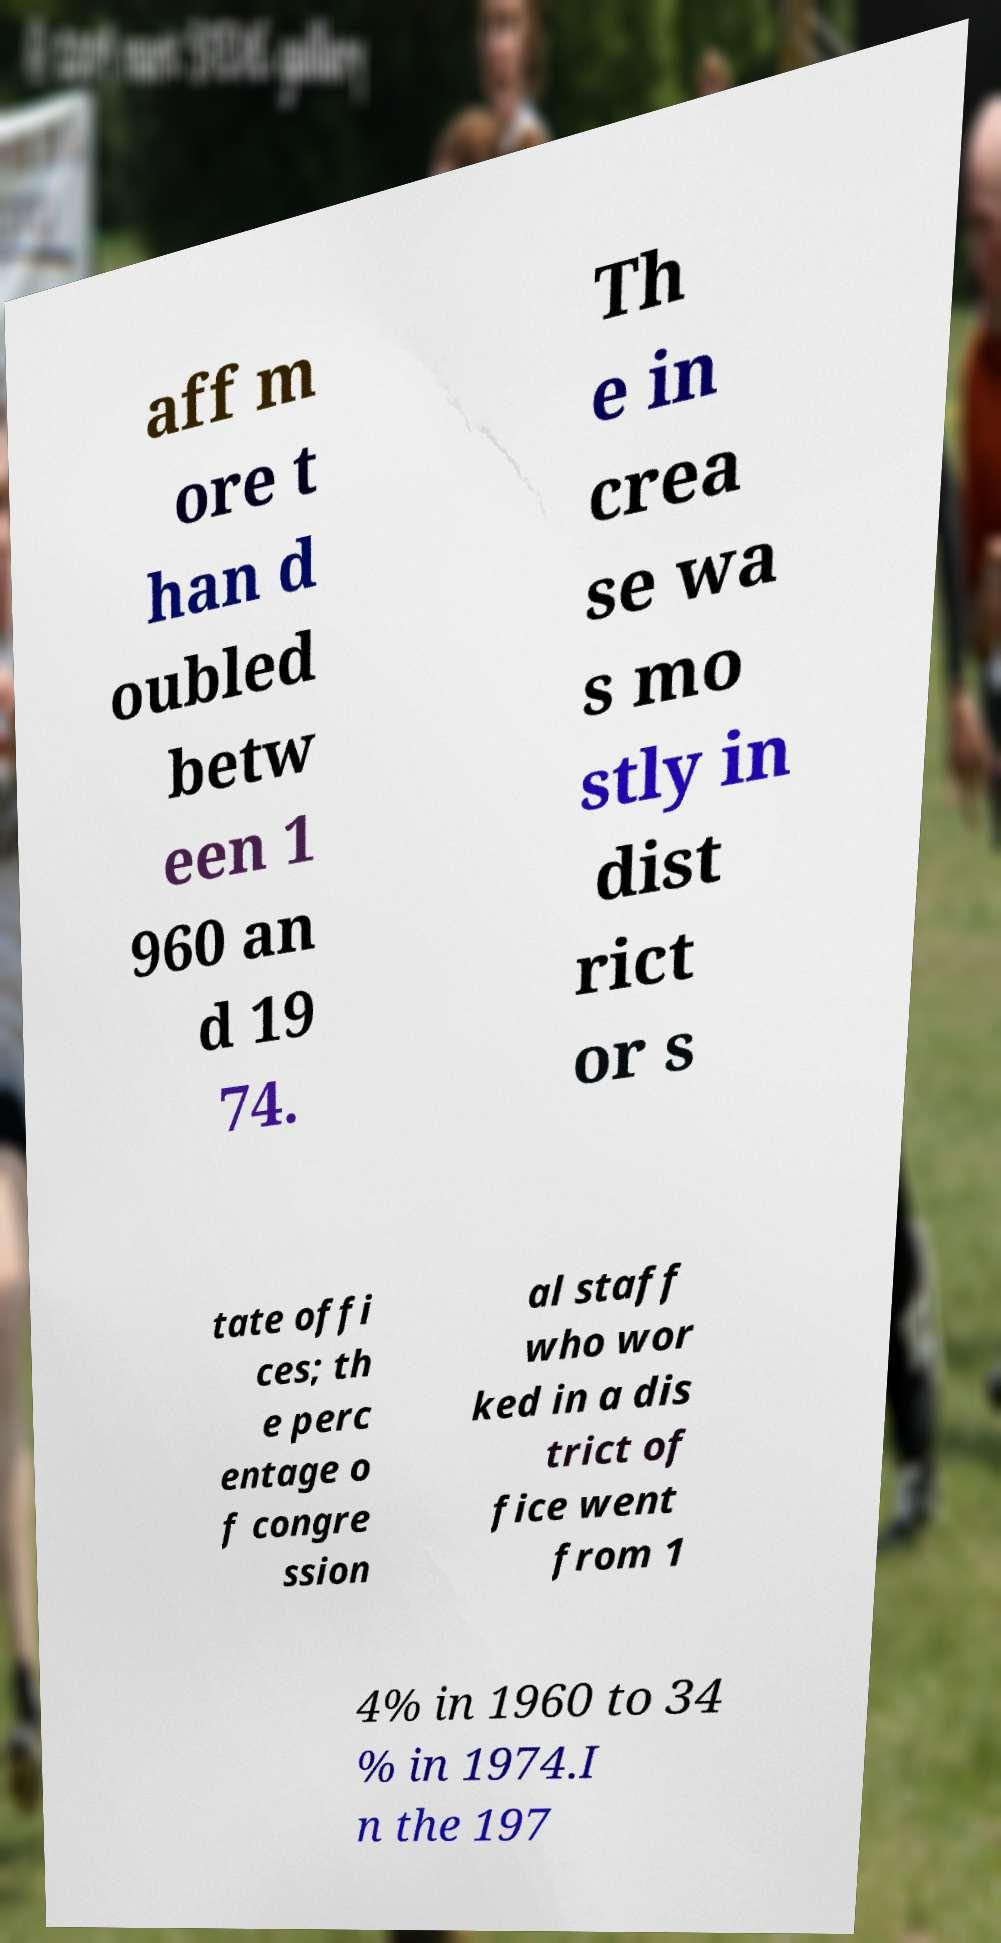Please identify and transcribe the text found in this image. aff m ore t han d oubled betw een 1 960 an d 19 74. Th e in crea se wa s mo stly in dist rict or s tate offi ces; th e perc entage o f congre ssion al staff who wor ked in a dis trict of fice went from 1 4% in 1960 to 34 % in 1974.I n the 197 